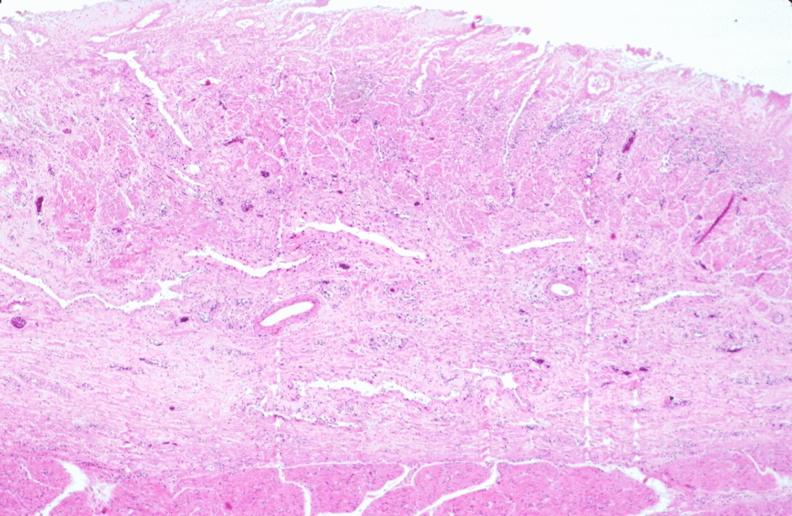what is stomach , necrotizing esophagitis and gastritis , sulfuric acid ingested?
Answer the question using a single word or phrase. As suicide attempt 